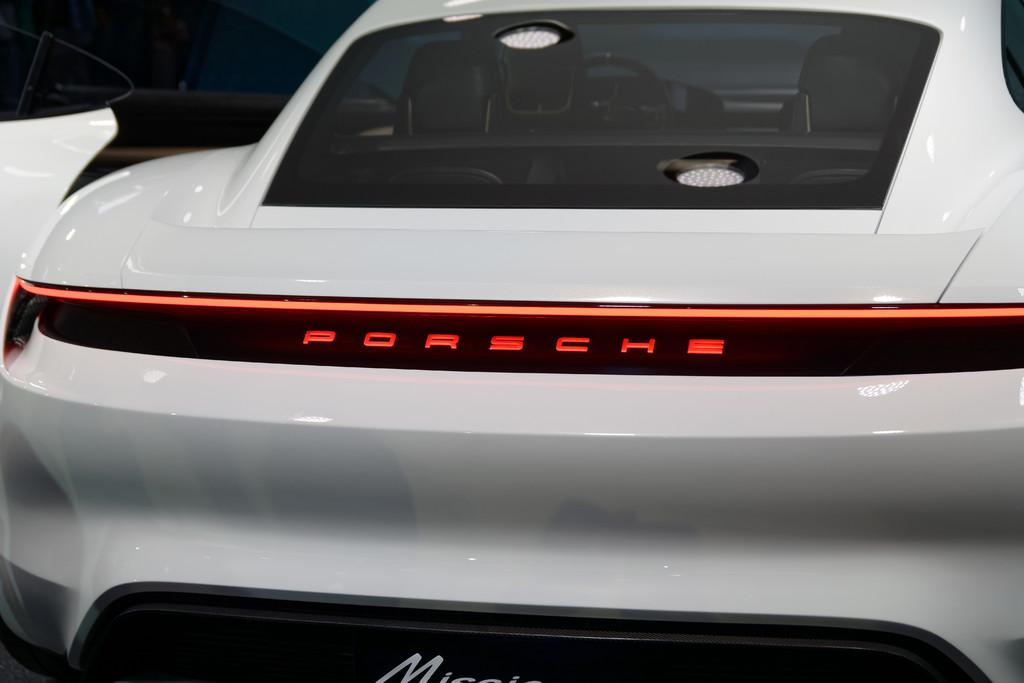What color is the vehicle in the image? The vehicle in the image is white. What else can be seen on the vehicle besides its color? There is text written on the vehicle. How does the shoe affect the temperature of the vehicle in the image? There is no shoe present in the image, so it cannot affect the temperature of the vehicle. 